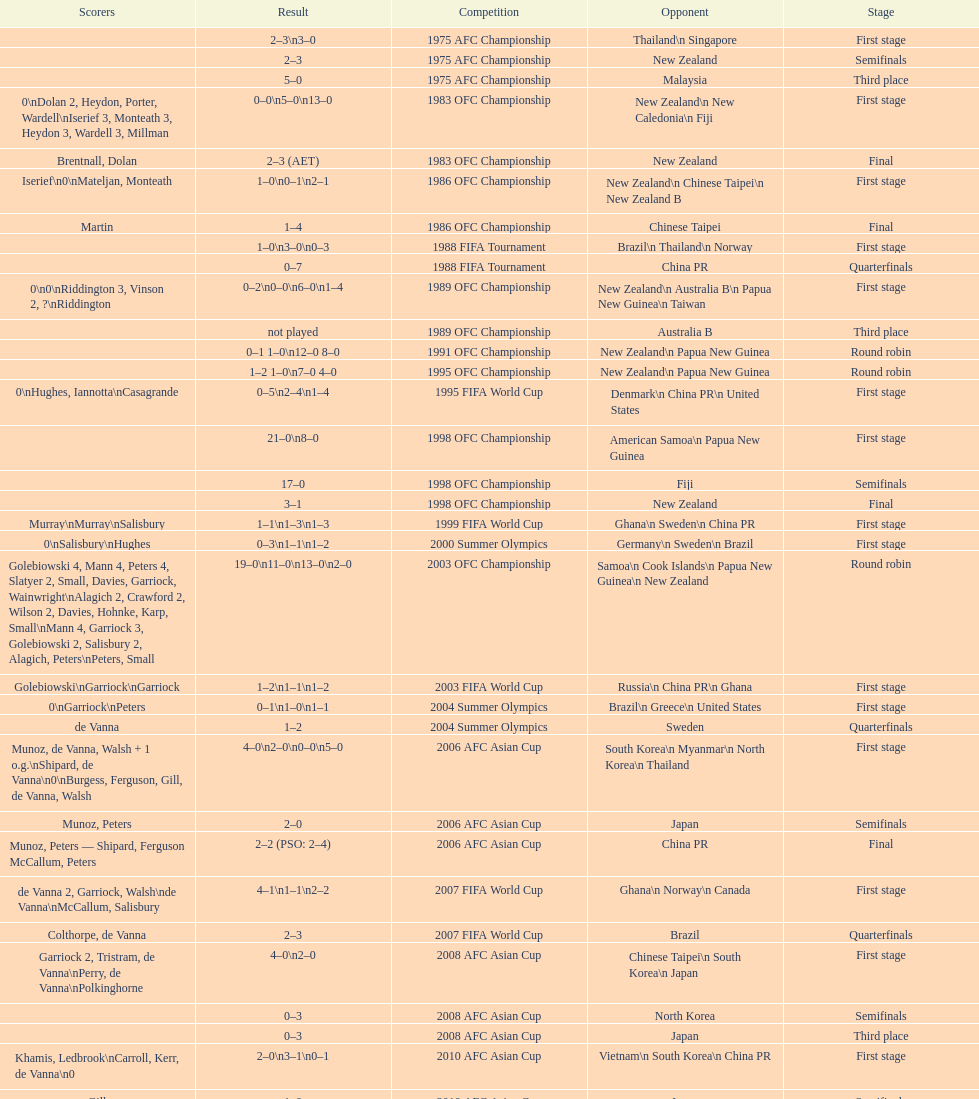What was the total goals made in the 1983 ofc championship? 18. 